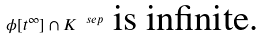Convert formula to latex. <formula><loc_0><loc_0><loc_500><loc_500>\phi [ t ^ { \infty } ] \cap K ^ { \ s e p } \text { is infinite.}</formula> 